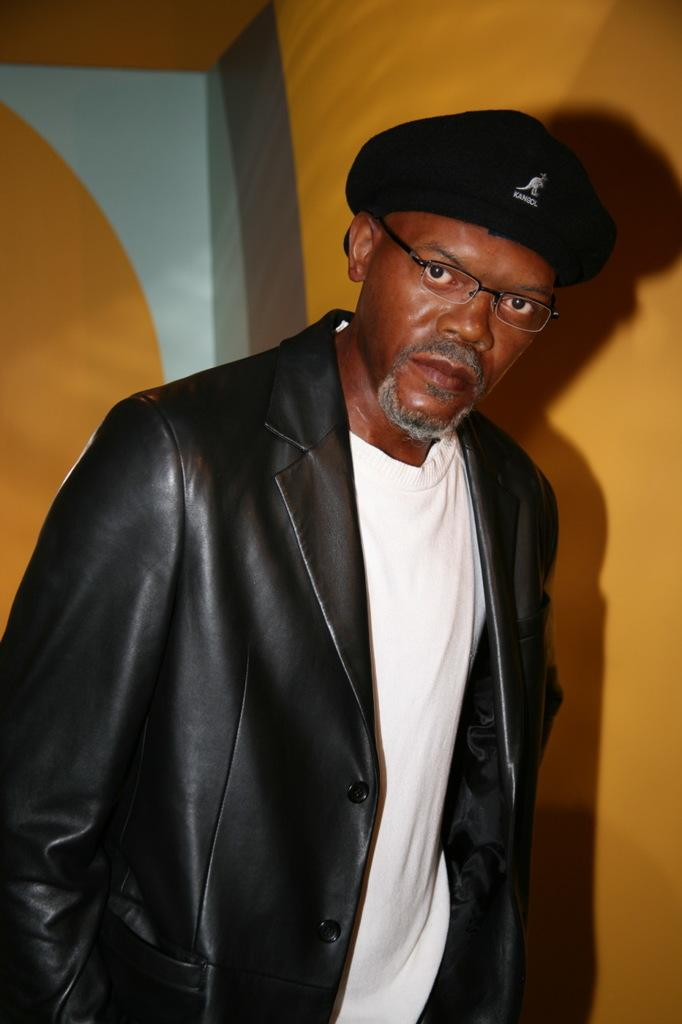What is the main subject of the image? There is a person in the image. What is the person doing in the image? The person is staring at the camera. What type of bait is the person holding in the image? There is no bait present in the image; the person is simply staring at the camera. What instrument is the person playing in the image? There is no instrument present in the image; the person is only staring at the camera. 